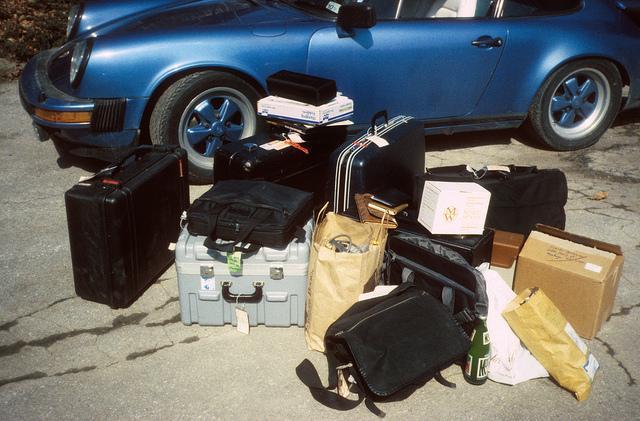How many brown bags are there?
Give a very brief answer. 1. How many suitcases can be seen?
Give a very brief answer. 4. How many handbags are there?
Give a very brief answer. 2. 